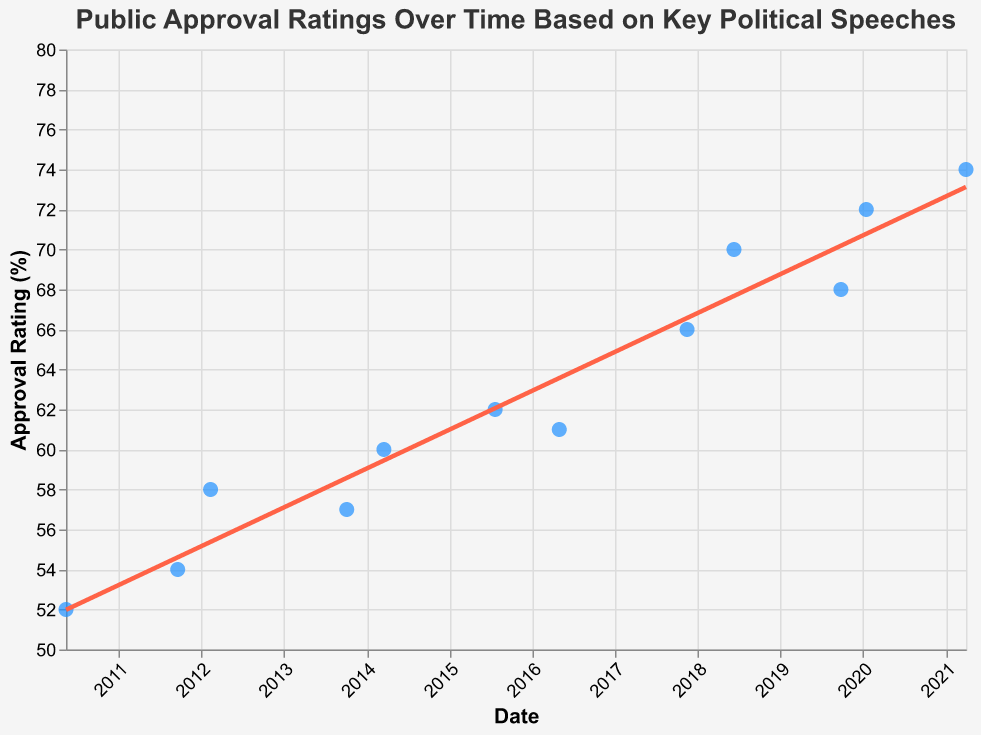How many speeches are represented on the figure? Count the total number of data points plotted. There are points for each speech.
Answer: 12 What are the titles of the speeches with the highest and lowest approval ratings? Identify the points with the highest and lowest y-values and check their corresponding speech titles through tooltips. The highest is the "Election Integrity Address" and the lowest is the "Healthcare Reform Speech."
Answer: "Election Integrity Address" (highest), "Healthcare Reform Speech" (lowest) What does the trend line indicate overall? The trend line connects the dots and visually indicates the overall direction of public approval ratings over time.
Answer: Increasing over time What is the average approval rating across all the speeches? Sum all approval ratings and divide by the number of speeches: (52 + 54 + 58 + 57 + 60 + 62 + 61 + 66 + 70 + 68 + 72 + 74) / 12
Answer: 63.33 How much did the approval rating increase from the “Healthcare Reform Speech” to the “Election Integrity Address”? Subtract the approval rating of the “Healthcare Reform Speech” from the “Election Integrity Address”: 74 - 52
Answer: 22 What is the median approval rating for these speeches? List all approval ratings, arrange in order, and find the middle value. The sorted ratings are (52, 54, 57, 58, 60, 61, 62, 66, 68, 70, 72, 74). The median is the average of the 6th and 7th values: (61 + 62) / 2
Answer: 61.5 Which speech had a higher approval rating, the "Immigration Law Proposal" or the "Economic Growth Speech"? Compare their y-values, where "Immigration Law Proposal" has 61 and "Economic Growth Speech" has 66.
Answer: "Economic Growth Speech" How does the approval rating of the "Climate Change Rally" compare to the "National Security Briefing"? Compare the approval ratings of "Climate Change Rally" (62) and "National Security Briefing" (60).
Answer: "Climate Change Rally" has a higher rating Which speech saw a higher improvement in approval rating compared to its predecessor, the "Climate Change Rally" or "Economic Growth Speech"? Calculate the difference from the preceding speeches: 
"Climate Change Rally - National Security Briefing": 62 - 60 = 2
"Economic Growth Speech - Immigration Law Proposal": 66 - 61 = 5.
The improvement is higher for "Economic Growth Speech".
Answer: "Economic Growth Speech" How does the trend line's slope suggest the public approval rating has changed over the years? A positive slope indicates an upward trend in approval ratings over the years.
Answer: Upward trend 